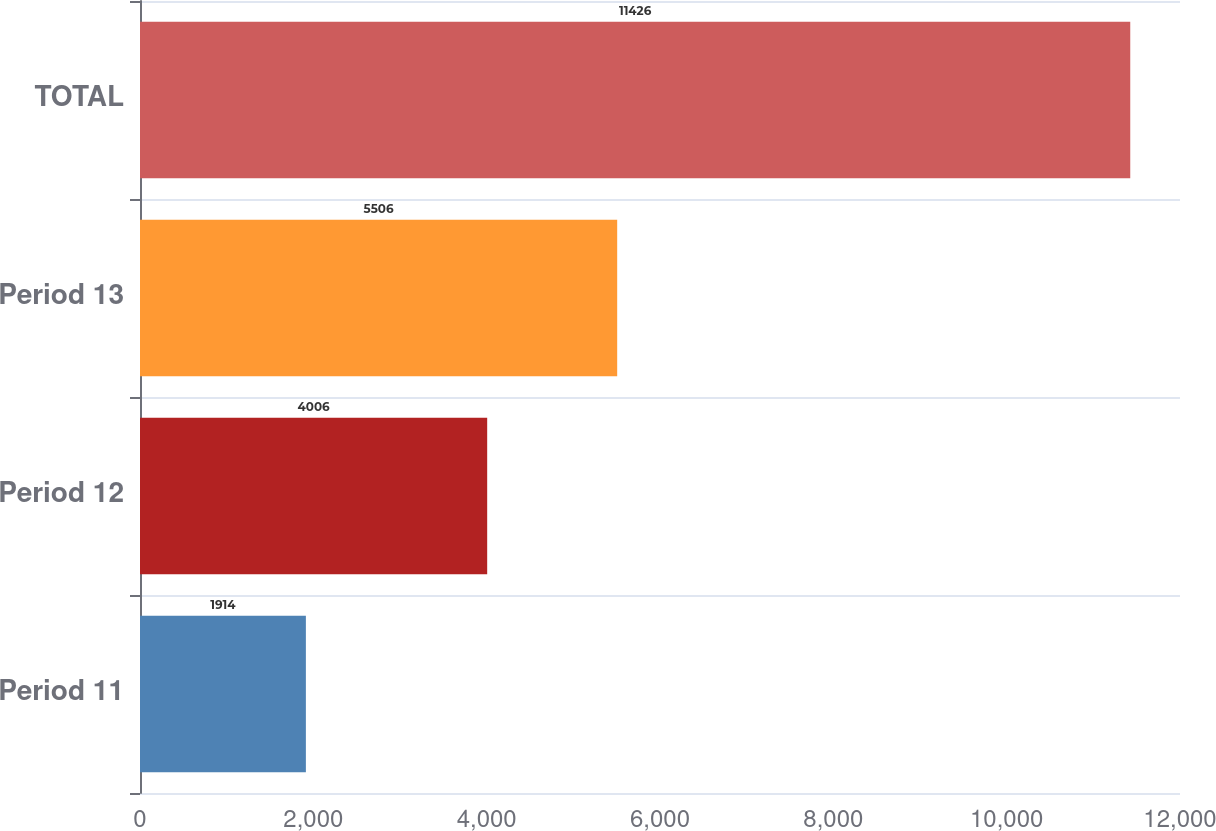Convert chart. <chart><loc_0><loc_0><loc_500><loc_500><bar_chart><fcel>Period 11<fcel>Period 12<fcel>Period 13<fcel>TOTAL<nl><fcel>1914<fcel>4006<fcel>5506<fcel>11426<nl></chart> 